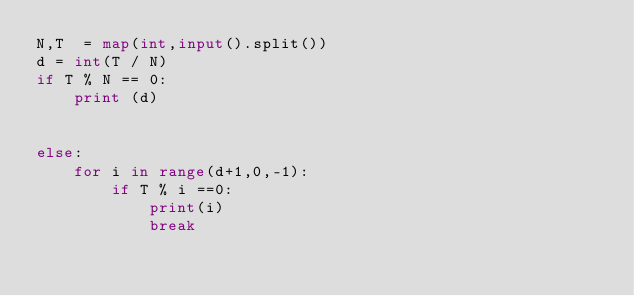<code> <loc_0><loc_0><loc_500><loc_500><_Python_>N,T  = map(int,input().split())
d = int(T / N)
if T % N == 0:
    print (d)


else:
    for i in range(d+1,0,-1):    
        if T % i ==0:
            print(i)
            break</code> 